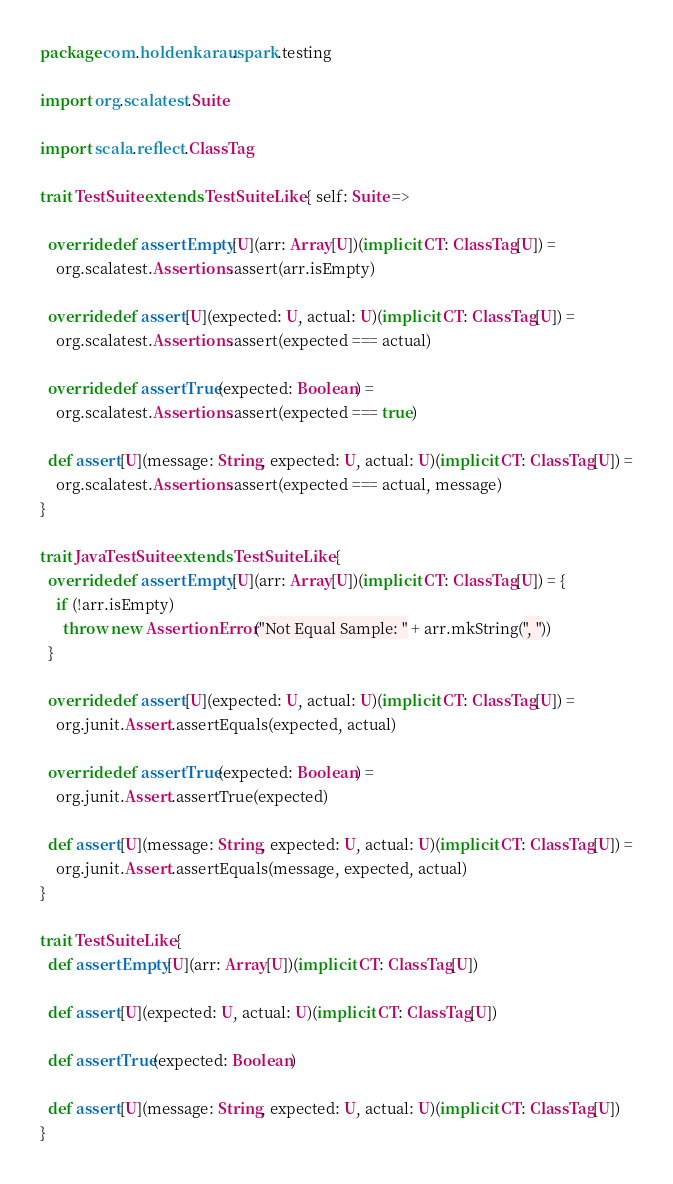<code> <loc_0><loc_0><loc_500><loc_500><_Scala_>package com.holdenkarau.spark.testing

import org.scalatest.Suite

import scala.reflect.ClassTag

trait TestSuite extends TestSuiteLike { self: Suite =>

  override def assertEmpty[U](arr: Array[U])(implicit CT: ClassTag[U]) =
    org.scalatest.Assertions.assert(arr.isEmpty)

  override def assert[U](expected: U, actual: U)(implicit CT: ClassTag[U]) =
    org.scalatest.Assertions.assert(expected === actual)

  override def assertTrue(expected: Boolean) =
    org.scalatest.Assertions.assert(expected === true)

  def assert[U](message: String, expected: U, actual: U)(implicit CT: ClassTag[U]) =
    org.scalatest.Assertions.assert(expected === actual, message)
}

trait JavaTestSuite extends TestSuiteLike {
  override def assertEmpty[U](arr: Array[U])(implicit CT: ClassTag[U]) = {
    if (!arr.isEmpty)
      throw new AssertionError("Not Equal Sample: " + arr.mkString(", "))
  }

  override def assert[U](expected: U, actual: U)(implicit CT: ClassTag[U]) =
    org.junit.Assert.assertEquals(expected, actual)

  override def assertTrue(expected: Boolean) =
    org.junit.Assert.assertTrue(expected)

  def assert[U](message: String, expected: U, actual: U)(implicit CT: ClassTag[U]) =
    org.junit.Assert.assertEquals(message, expected, actual)
}

trait TestSuiteLike {
  def assertEmpty[U](arr: Array[U])(implicit CT: ClassTag[U])

  def assert[U](expected: U, actual: U)(implicit CT: ClassTag[U])

  def assertTrue(expected: Boolean)

  def assert[U](message: String, expected: U, actual: U)(implicit CT: ClassTag[U])
}

</code> 